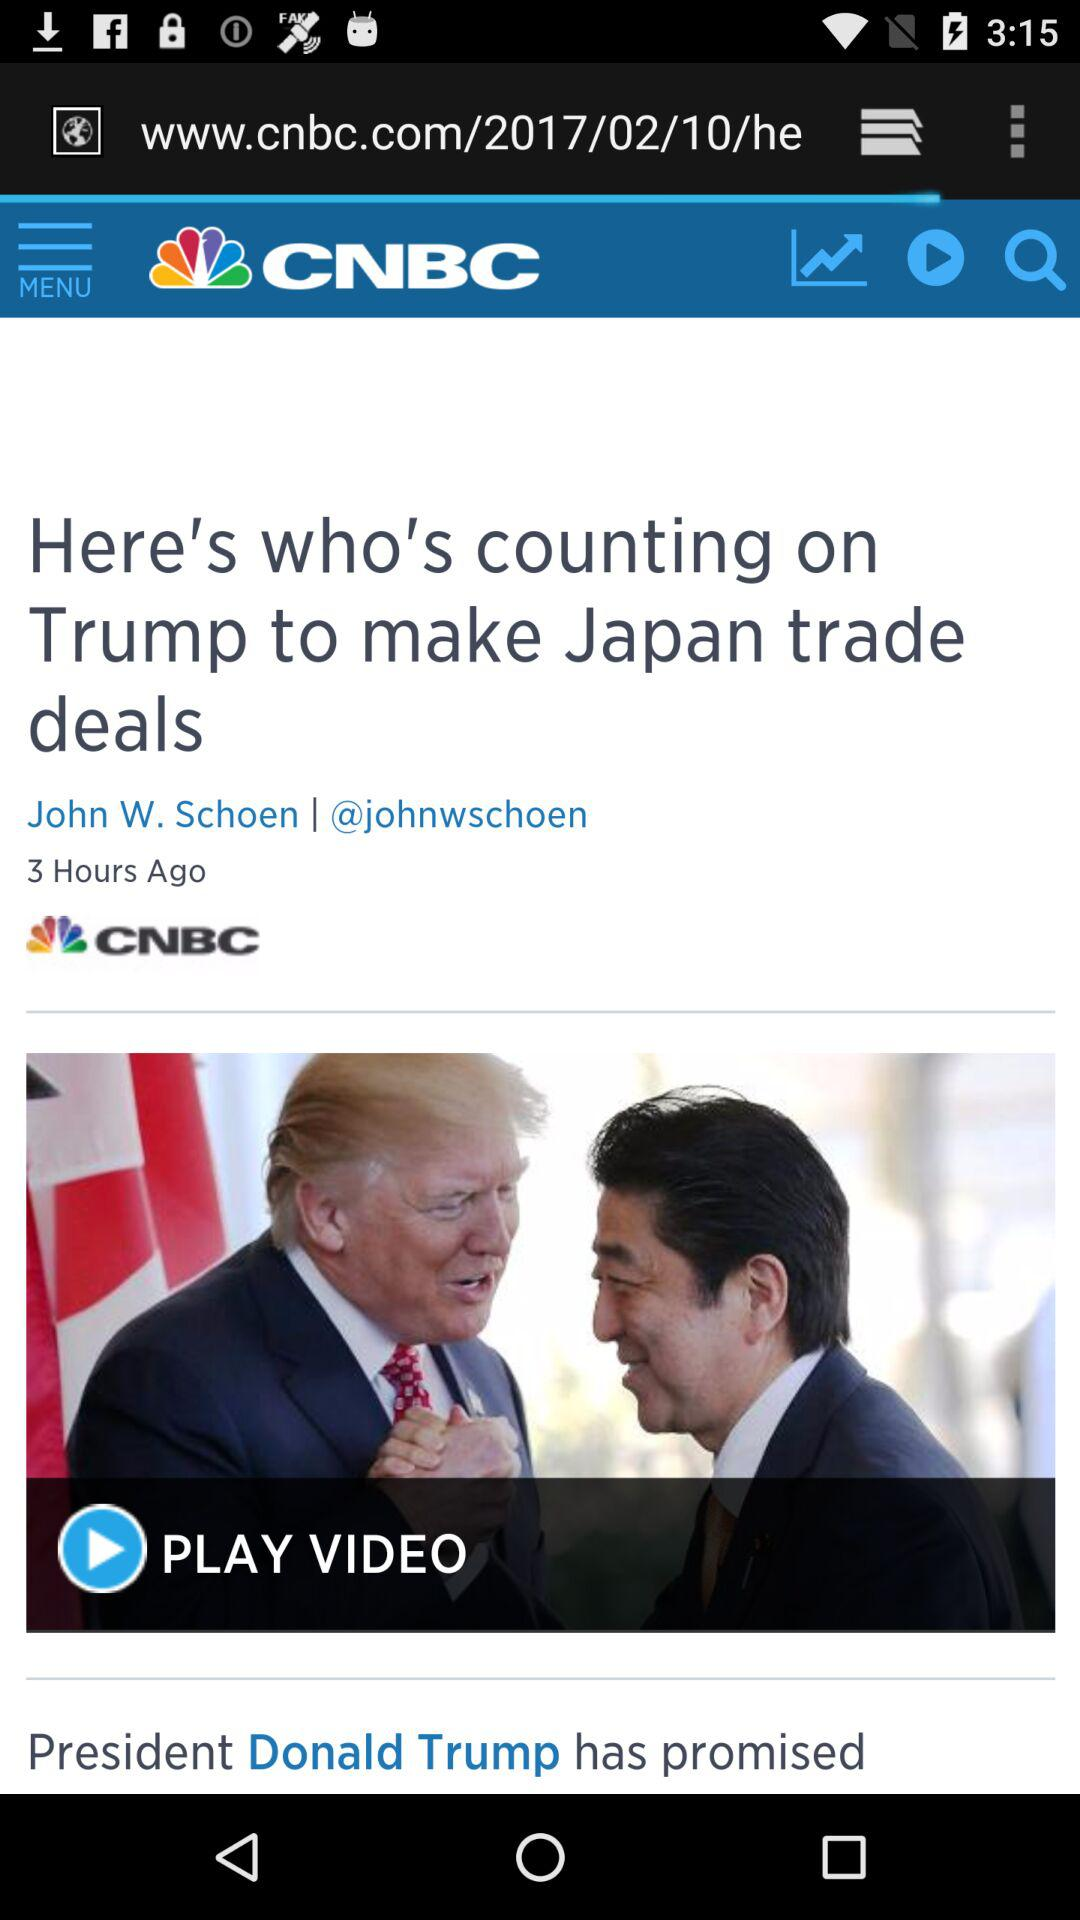What is the headline? The headline is "Here's who's counting on Trump to make Japan trade deals". 